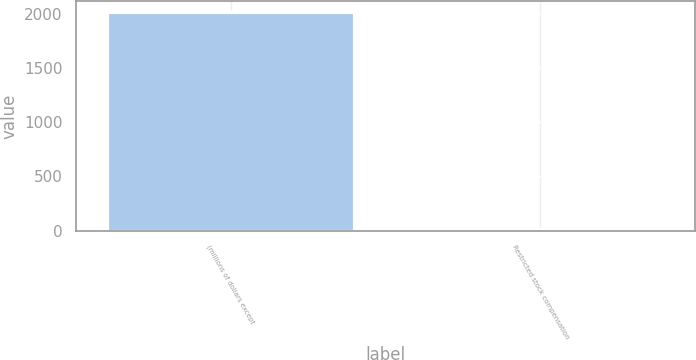Convert chart. <chart><loc_0><loc_0><loc_500><loc_500><bar_chart><fcel>(millions of dollars except<fcel>Restricted stock compensation<nl><fcel>2014<fcel>15.1<nl></chart> 